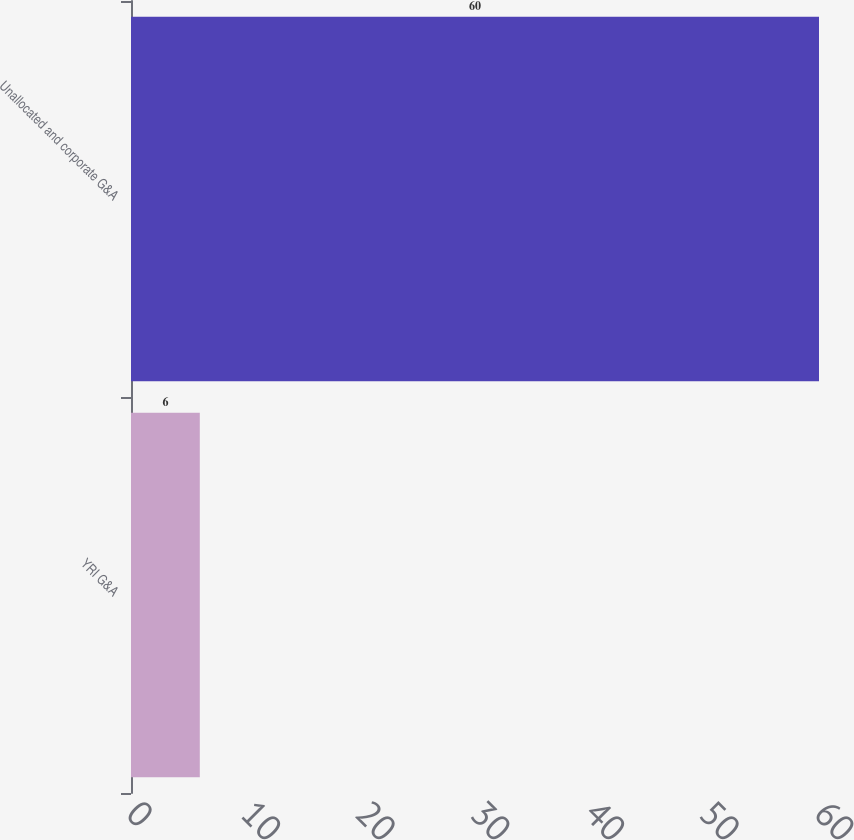Convert chart to OTSL. <chart><loc_0><loc_0><loc_500><loc_500><bar_chart><fcel>YRI G&A<fcel>Unallocated and corporate G&A<nl><fcel>6<fcel>60<nl></chart> 